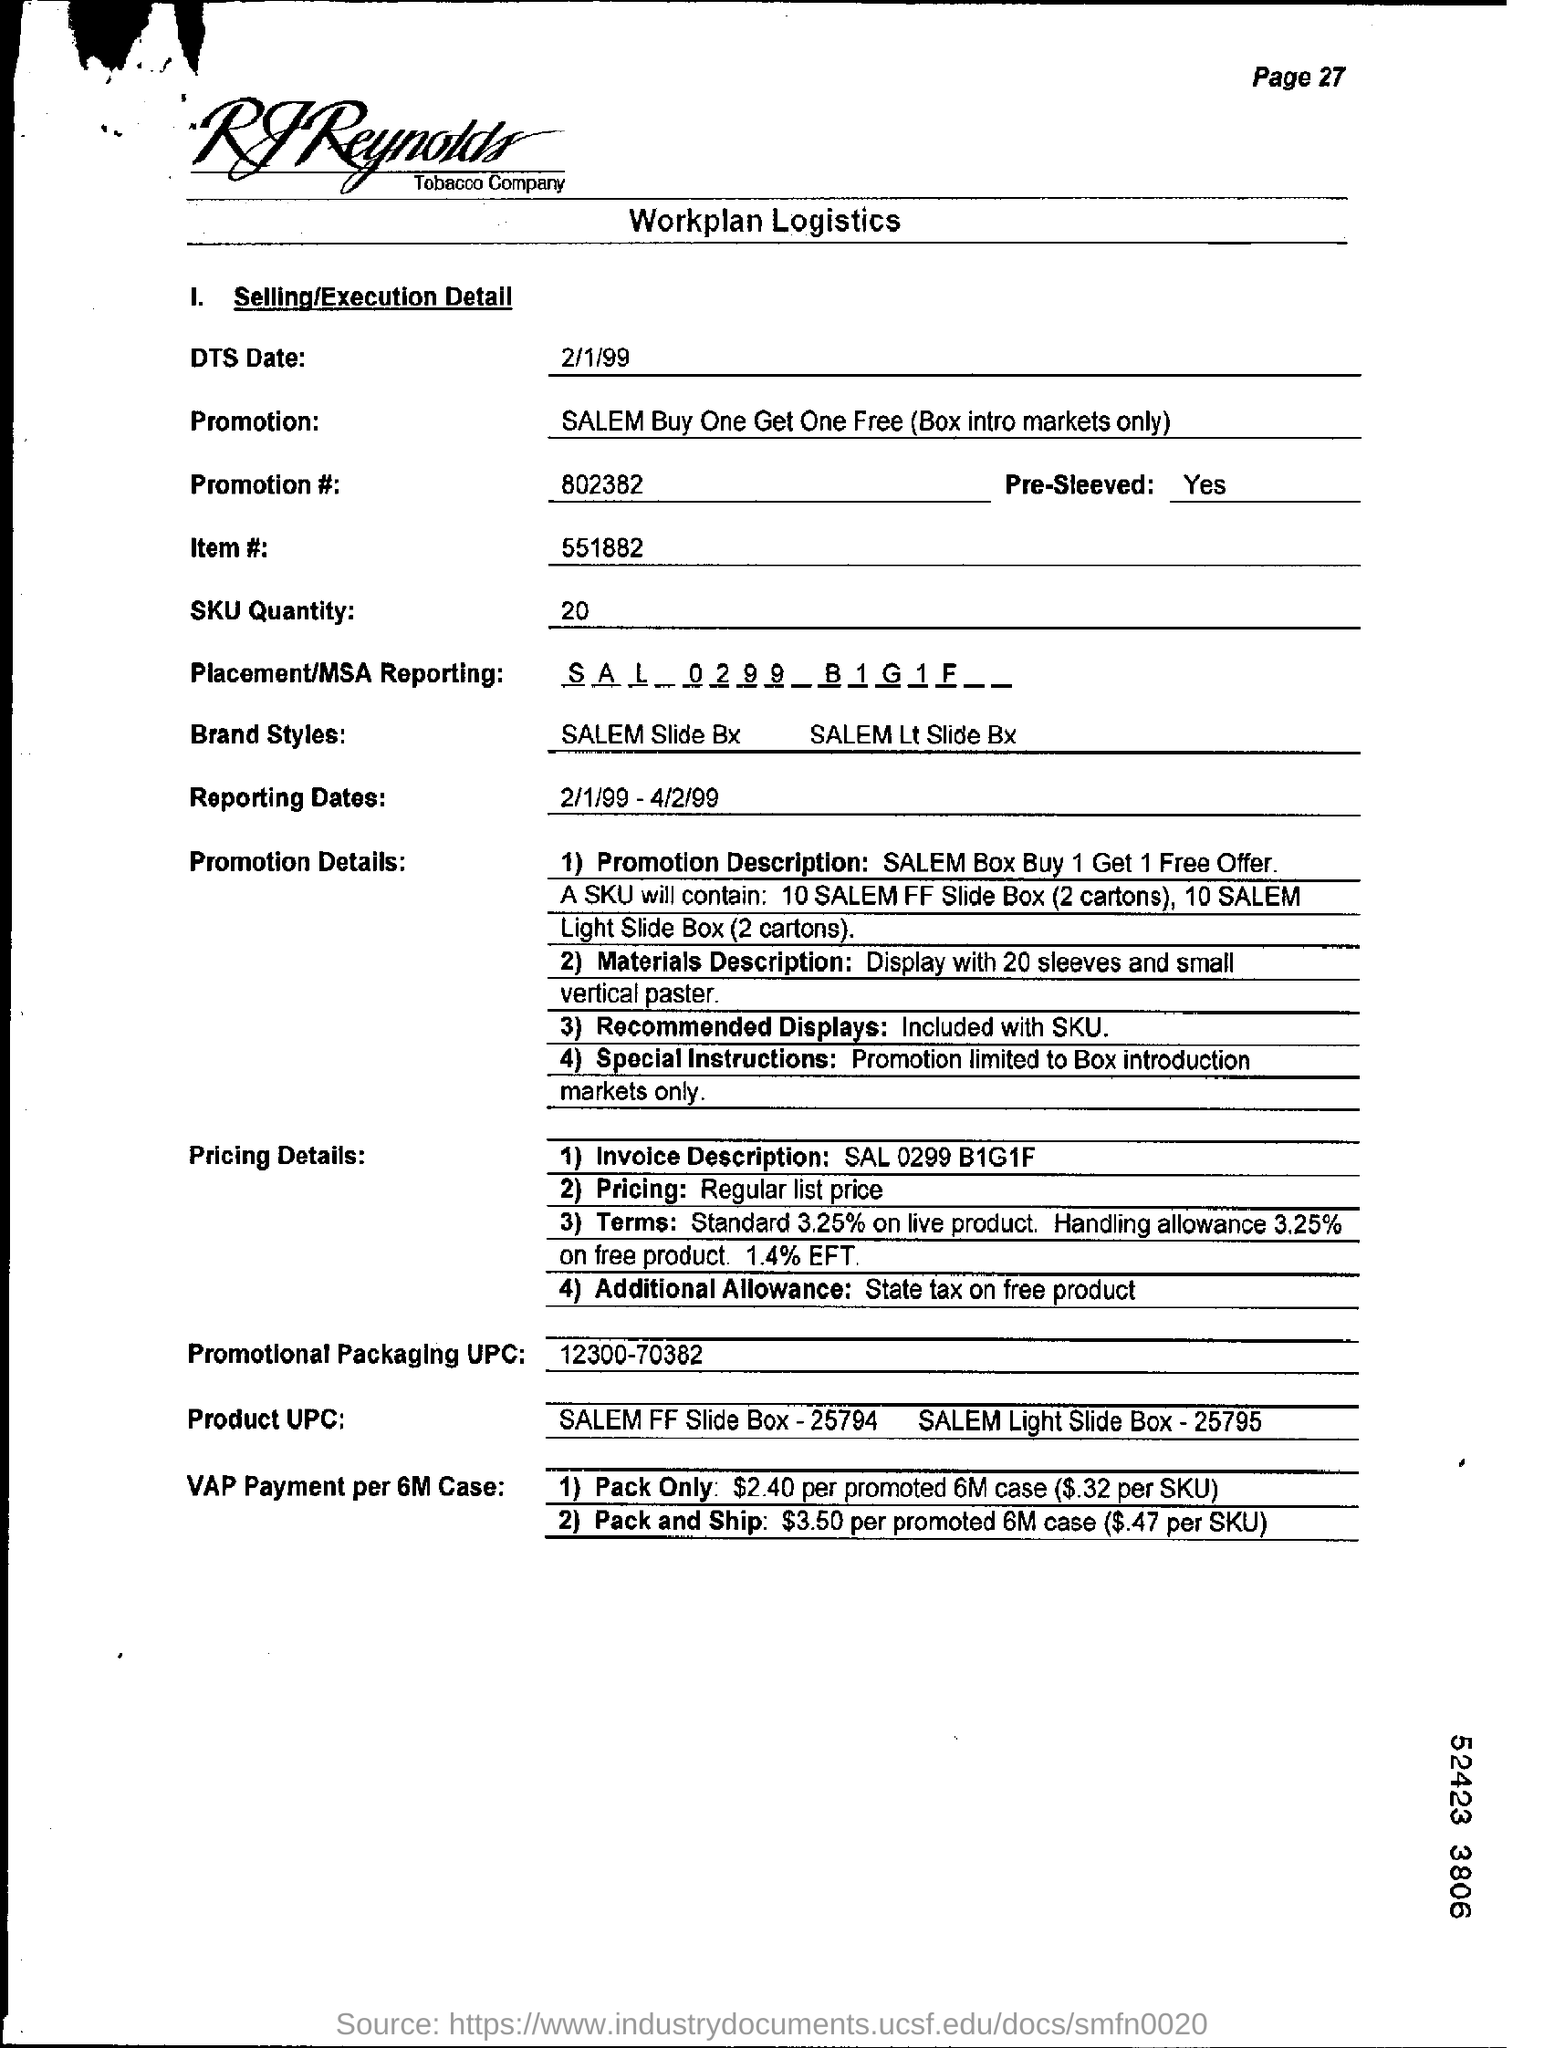Mention a couple of crucial points in this snapshot. The SKU quantity as per the document is 20... The item number mentioned in the document is 551882... The promotion number given in the document is 802382... The reporting dates specified in the document are from February 1, 1999 to April 2, 1999. The document in question pertains to the workplan logistics of RJ Reynolds Tobacco Company. 